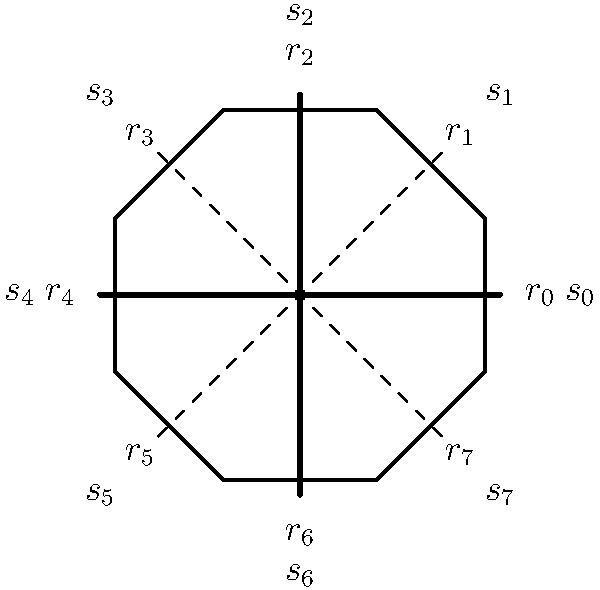In the layout of a traditional Norwegian stave church, the octagonal base represents the dihedral group $D_8$. Given that $r_k$ represents a rotation by $\frac{k\pi}{4}$ radians and $s_k$ represents a reflection across the line at an angle of $\frac{k\pi}{8}$ with the positive x-axis, what is the result of the group operation $s_3 \circ r_5$? To find the result of $s_3 \circ r_5$, we need to follow these steps:

1) First, apply $r_5$, which is a rotation by $\frac{5\pi}{4}$ radians (or 225°) counterclockwise.

2) Then, apply $s_3$, which is a reflection across the line at an angle of $\frac{3\pi}{8}$ with the positive x-axis.

3) In the dihedral group, a reflection followed by a rotation can always be expressed as another reflection.

4) The resulting reflection line can be found by rotating the original reflection line ($s_3$) by half the angle of rotation ($r_5$).

5) Half of $\frac{5\pi}{4}$ is $\frac{5\pi}{8}$.

6) So, we need to rotate the line of $s_3$ by $\frac{5\pi}{8}$ counterclockwise.

7) $s_3$ is at $\frac{3\pi}{8}$, so the new reflection line will be at $\frac{3\pi}{8} + \frac{5\pi}{8} = \pi$.

8) The reflection across the line at an angle of $\pi$ with the positive x-axis is $s_4$.

Therefore, $s_3 \circ r_5 = s_4$.
Answer: $s_4$ 